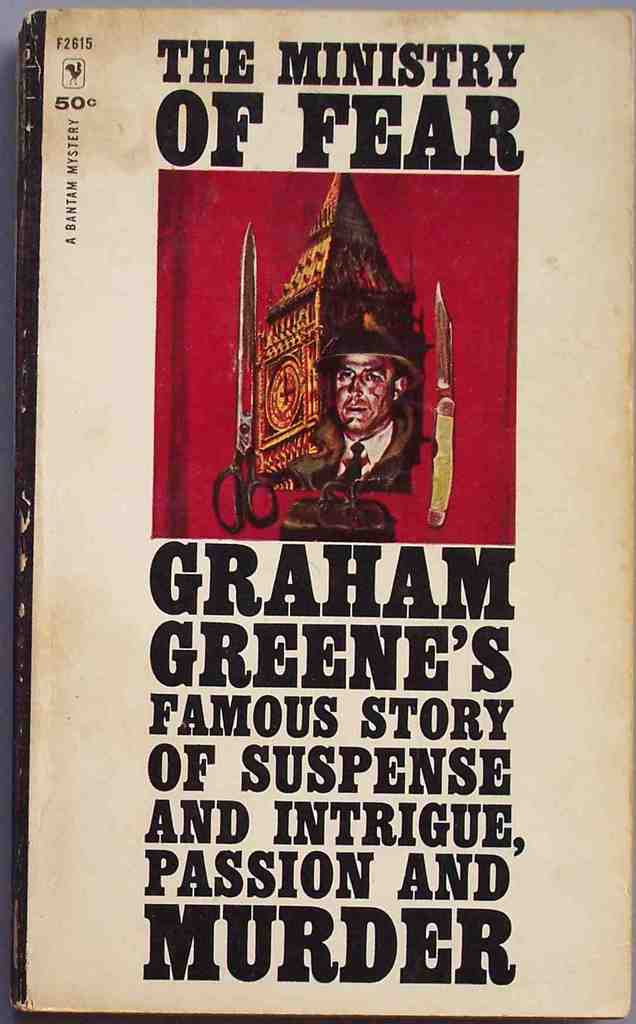What symbolic meanings could the feathered hat in the illustration represent in the context of the novel? The feathered hat on the man's face in the cover art likely symbolizes elements of disguise or hidden identity, which are common themes in spy or suspense narratives like 'The Ministry of Fear'. This could infer that the protagonist adopts different personas or is involved in covert operations, aligning with the story's elements of intrigue and espionage. 